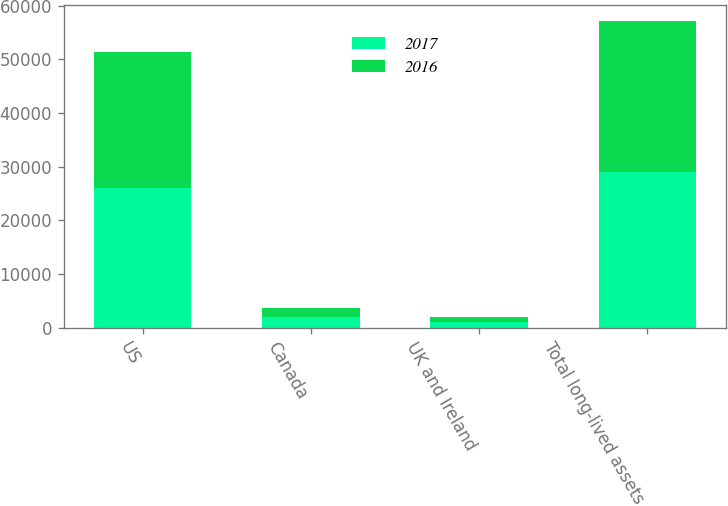<chart> <loc_0><loc_0><loc_500><loc_500><stacked_bar_chart><ecel><fcel>US<fcel>Canada<fcel>UK and Ireland<fcel>Total long-lived assets<nl><fcel>2017<fcel>26083<fcel>1915<fcel>1063<fcel>29061<nl><fcel>2016<fcel>25359<fcel>1816<fcel>967<fcel>28142<nl></chart> 